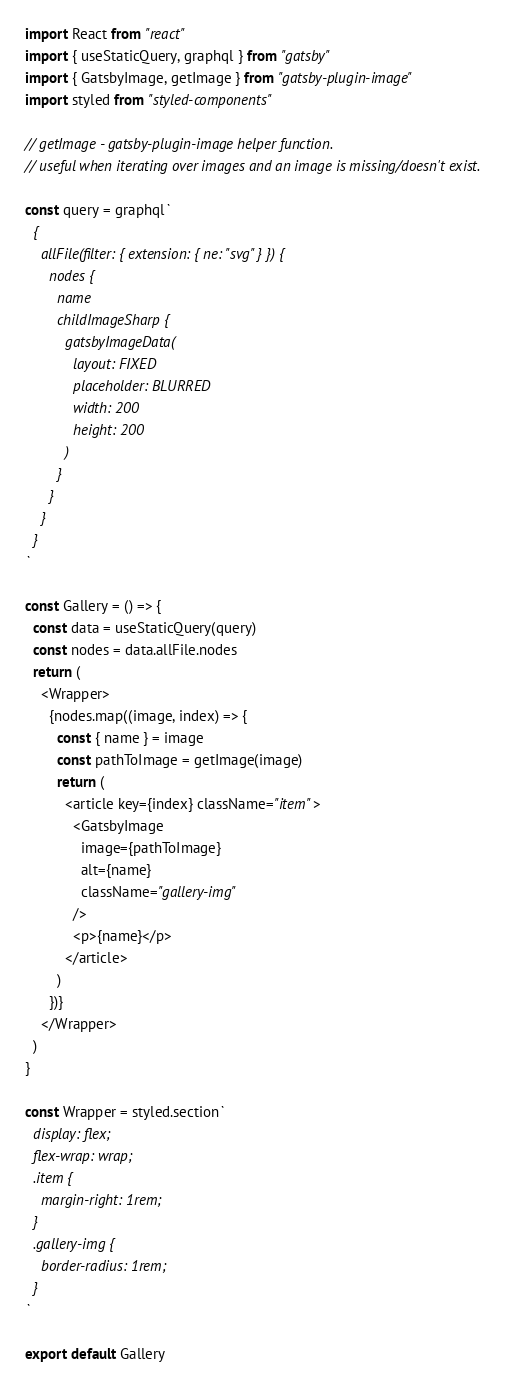Convert code to text. <code><loc_0><loc_0><loc_500><loc_500><_JavaScript_>import React from "react"
import { useStaticQuery, graphql } from "gatsby"
import { GatsbyImage, getImage } from "gatsby-plugin-image"
import styled from "styled-components"

// getImage - gatsby-plugin-image helper function.
// useful when iterating over images and an image is missing/doesn't exist.

const query = graphql`
  {
    allFile(filter: { extension: { ne: "svg" } }) {
      nodes {
        name
        childImageSharp {
          gatsbyImageData(
            layout: FIXED
            placeholder: BLURRED
            width: 200
            height: 200
          )
        }
      }
    }
  }
`

const Gallery = () => {
  const data = useStaticQuery(query)
  const nodes = data.allFile.nodes
  return (
    <Wrapper>
      {nodes.map((image, index) => {
        const { name } = image
        const pathToImage = getImage(image)
        return (
          <article key={index} className="item">
            <GatsbyImage
              image={pathToImage}
              alt={name}
              className="gallery-img"
            />
            <p>{name}</p>
          </article>
        )
      })}
    </Wrapper>
  )
}

const Wrapper = styled.section`
  display: flex;
  flex-wrap: wrap;
  .item {
    margin-right: 1rem;
  }
  .gallery-img {
    border-radius: 1rem;
  }
`

export default Gallery
</code> 